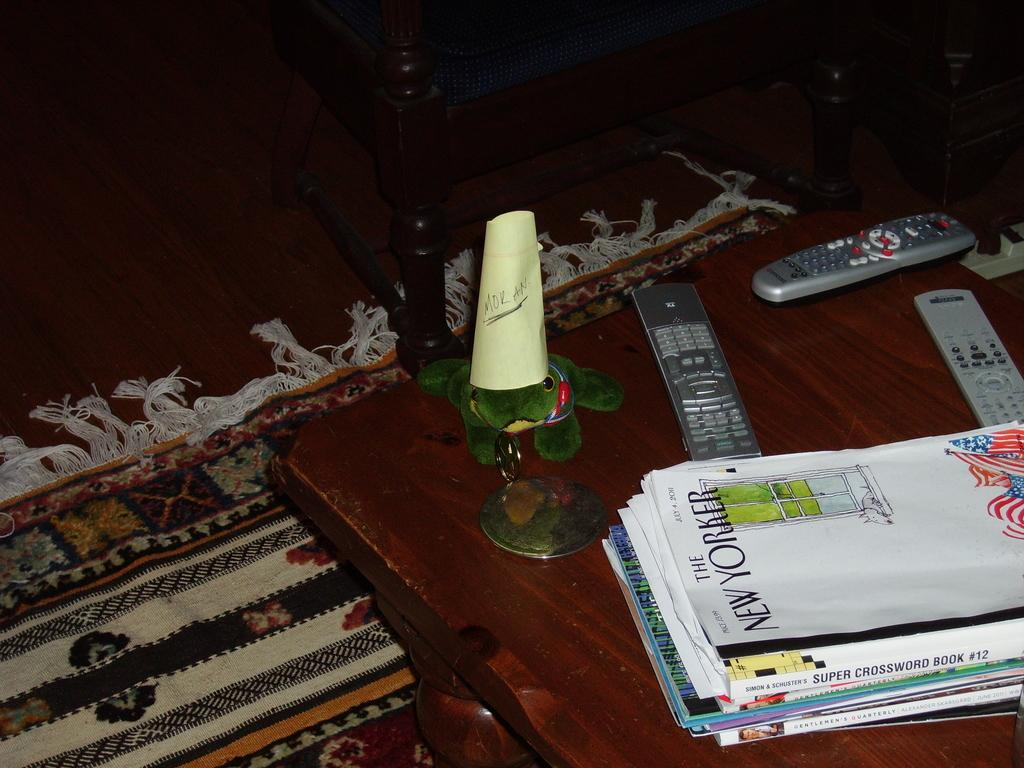<image>
Render a clear and concise summary of the photo. A coffee table with several remote controls and a copy of the New Yorker on it. 